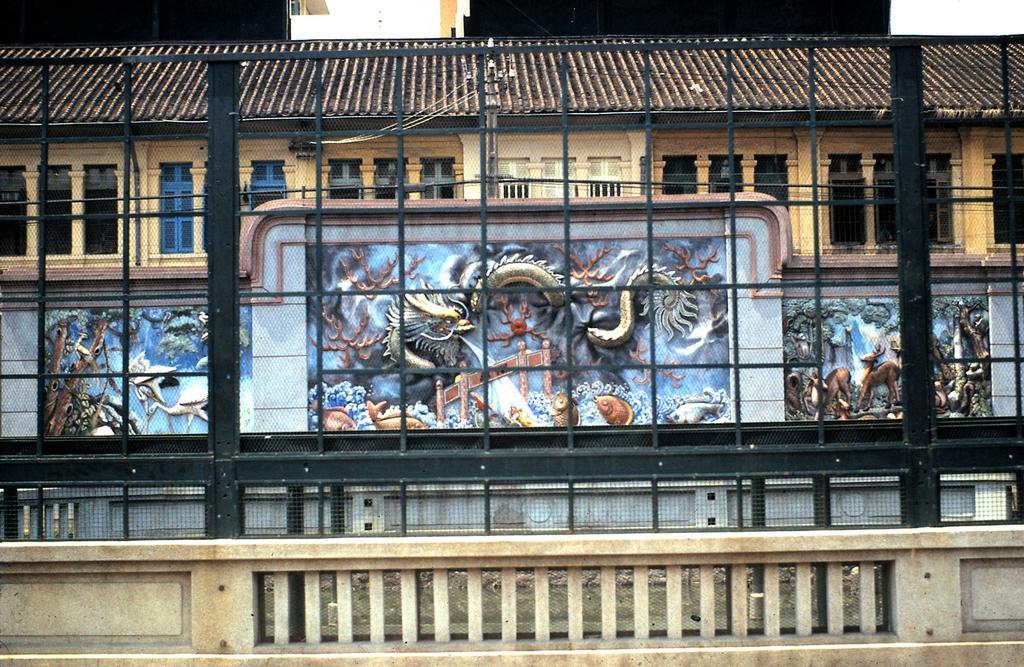Please provide a concise description of this image. In this image we can see buildings with windows, fence and we can also see the carved sculptures. 